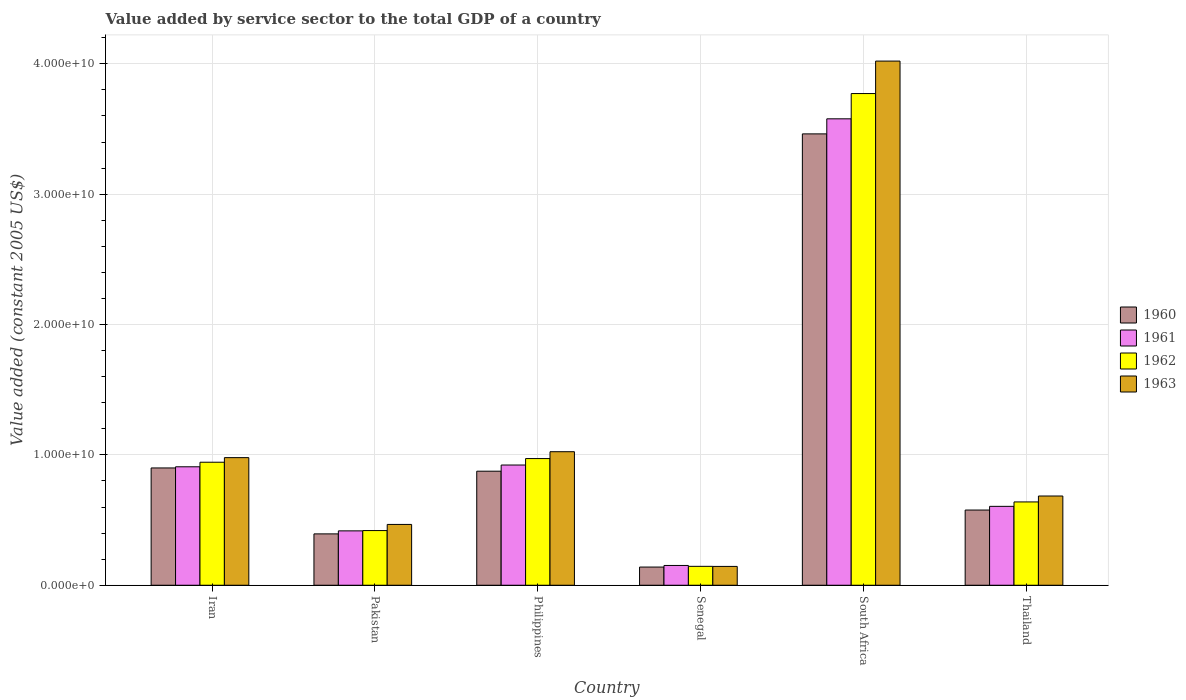How many different coloured bars are there?
Offer a terse response. 4. Are the number of bars per tick equal to the number of legend labels?
Provide a succinct answer. Yes. How many bars are there on the 2nd tick from the right?
Give a very brief answer. 4. What is the value added by service sector in 1960 in Pakistan?
Provide a short and direct response. 3.94e+09. Across all countries, what is the maximum value added by service sector in 1962?
Provide a short and direct response. 3.77e+1. Across all countries, what is the minimum value added by service sector in 1961?
Give a very brief answer. 1.52e+09. In which country was the value added by service sector in 1960 maximum?
Your answer should be compact. South Africa. In which country was the value added by service sector in 1961 minimum?
Your response must be concise. Senegal. What is the total value added by service sector in 1960 in the graph?
Offer a terse response. 6.35e+1. What is the difference between the value added by service sector in 1962 in Senegal and that in South Africa?
Provide a short and direct response. -3.63e+1. What is the difference between the value added by service sector in 1962 in South Africa and the value added by service sector in 1961 in Thailand?
Offer a terse response. 3.17e+1. What is the average value added by service sector in 1961 per country?
Your answer should be compact. 1.10e+1. What is the difference between the value added by service sector of/in 1960 and value added by service sector of/in 1963 in Senegal?
Offer a very short reply. -4.94e+07. In how many countries, is the value added by service sector in 1961 greater than 2000000000 US$?
Offer a terse response. 5. What is the ratio of the value added by service sector in 1963 in Senegal to that in Thailand?
Keep it short and to the point. 0.21. Is the difference between the value added by service sector in 1960 in Philippines and Senegal greater than the difference between the value added by service sector in 1963 in Philippines and Senegal?
Provide a short and direct response. No. What is the difference between the highest and the second highest value added by service sector in 1962?
Provide a succinct answer. -2.80e+1. What is the difference between the highest and the lowest value added by service sector in 1962?
Your answer should be compact. 3.63e+1. In how many countries, is the value added by service sector in 1961 greater than the average value added by service sector in 1961 taken over all countries?
Ensure brevity in your answer.  1. Is it the case that in every country, the sum of the value added by service sector in 1960 and value added by service sector in 1963 is greater than the value added by service sector in 1961?
Your answer should be compact. Yes. How many bars are there?
Your answer should be compact. 24. How many countries are there in the graph?
Your answer should be compact. 6. Are the values on the major ticks of Y-axis written in scientific E-notation?
Your answer should be very brief. Yes. How many legend labels are there?
Your answer should be compact. 4. What is the title of the graph?
Your answer should be compact. Value added by service sector to the total GDP of a country. What is the label or title of the X-axis?
Ensure brevity in your answer.  Country. What is the label or title of the Y-axis?
Offer a terse response. Value added (constant 2005 US$). What is the Value added (constant 2005 US$) in 1960 in Iran?
Provide a short and direct response. 9.00e+09. What is the Value added (constant 2005 US$) in 1961 in Iran?
Provide a short and direct response. 9.09e+09. What is the Value added (constant 2005 US$) of 1962 in Iran?
Your answer should be compact. 9.44e+09. What is the Value added (constant 2005 US$) in 1963 in Iran?
Offer a terse response. 9.79e+09. What is the Value added (constant 2005 US$) of 1960 in Pakistan?
Offer a terse response. 3.94e+09. What is the Value added (constant 2005 US$) of 1961 in Pakistan?
Offer a very short reply. 4.17e+09. What is the Value added (constant 2005 US$) of 1962 in Pakistan?
Your response must be concise. 4.19e+09. What is the Value added (constant 2005 US$) in 1963 in Pakistan?
Your answer should be compact. 4.66e+09. What is the Value added (constant 2005 US$) of 1960 in Philippines?
Ensure brevity in your answer.  8.75e+09. What is the Value added (constant 2005 US$) in 1961 in Philippines?
Offer a terse response. 9.22e+09. What is the Value added (constant 2005 US$) in 1962 in Philippines?
Your response must be concise. 9.72e+09. What is the Value added (constant 2005 US$) of 1963 in Philippines?
Your answer should be very brief. 1.02e+1. What is the Value added (constant 2005 US$) in 1960 in Senegal?
Make the answer very short. 1.39e+09. What is the Value added (constant 2005 US$) of 1961 in Senegal?
Ensure brevity in your answer.  1.52e+09. What is the Value added (constant 2005 US$) of 1962 in Senegal?
Offer a very short reply. 1.45e+09. What is the Value added (constant 2005 US$) of 1963 in Senegal?
Keep it short and to the point. 1.44e+09. What is the Value added (constant 2005 US$) of 1960 in South Africa?
Your answer should be compact. 3.46e+1. What is the Value added (constant 2005 US$) of 1961 in South Africa?
Keep it short and to the point. 3.58e+1. What is the Value added (constant 2005 US$) in 1962 in South Africa?
Your response must be concise. 3.77e+1. What is the Value added (constant 2005 US$) in 1963 in South Africa?
Offer a very short reply. 4.02e+1. What is the Value added (constant 2005 US$) in 1960 in Thailand?
Keep it short and to the point. 5.77e+09. What is the Value added (constant 2005 US$) in 1961 in Thailand?
Offer a very short reply. 6.05e+09. What is the Value added (constant 2005 US$) in 1962 in Thailand?
Ensure brevity in your answer.  6.39e+09. What is the Value added (constant 2005 US$) of 1963 in Thailand?
Offer a very short reply. 6.84e+09. Across all countries, what is the maximum Value added (constant 2005 US$) in 1960?
Offer a very short reply. 3.46e+1. Across all countries, what is the maximum Value added (constant 2005 US$) of 1961?
Keep it short and to the point. 3.58e+1. Across all countries, what is the maximum Value added (constant 2005 US$) in 1962?
Ensure brevity in your answer.  3.77e+1. Across all countries, what is the maximum Value added (constant 2005 US$) in 1963?
Give a very brief answer. 4.02e+1. Across all countries, what is the minimum Value added (constant 2005 US$) of 1960?
Your response must be concise. 1.39e+09. Across all countries, what is the minimum Value added (constant 2005 US$) in 1961?
Make the answer very short. 1.52e+09. Across all countries, what is the minimum Value added (constant 2005 US$) of 1962?
Offer a terse response. 1.45e+09. Across all countries, what is the minimum Value added (constant 2005 US$) in 1963?
Make the answer very short. 1.44e+09. What is the total Value added (constant 2005 US$) in 1960 in the graph?
Provide a succinct answer. 6.35e+1. What is the total Value added (constant 2005 US$) in 1961 in the graph?
Your response must be concise. 6.58e+1. What is the total Value added (constant 2005 US$) in 1962 in the graph?
Give a very brief answer. 6.89e+1. What is the total Value added (constant 2005 US$) in 1963 in the graph?
Your answer should be compact. 7.32e+1. What is the difference between the Value added (constant 2005 US$) in 1960 in Iran and that in Pakistan?
Make the answer very short. 5.06e+09. What is the difference between the Value added (constant 2005 US$) of 1961 in Iran and that in Pakistan?
Provide a short and direct response. 4.92e+09. What is the difference between the Value added (constant 2005 US$) in 1962 in Iran and that in Pakistan?
Offer a very short reply. 5.24e+09. What is the difference between the Value added (constant 2005 US$) of 1963 in Iran and that in Pakistan?
Ensure brevity in your answer.  5.12e+09. What is the difference between the Value added (constant 2005 US$) in 1960 in Iran and that in Philippines?
Offer a terse response. 2.49e+08. What is the difference between the Value added (constant 2005 US$) of 1961 in Iran and that in Philippines?
Your answer should be very brief. -1.35e+08. What is the difference between the Value added (constant 2005 US$) of 1962 in Iran and that in Philippines?
Your answer should be very brief. -2.80e+08. What is the difference between the Value added (constant 2005 US$) in 1963 in Iran and that in Philippines?
Keep it short and to the point. -4.54e+08. What is the difference between the Value added (constant 2005 US$) of 1960 in Iran and that in Senegal?
Ensure brevity in your answer.  7.60e+09. What is the difference between the Value added (constant 2005 US$) of 1961 in Iran and that in Senegal?
Your answer should be compact. 7.57e+09. What is the difference between the Value added (constant 2005 US$) in 1962 in Iran and that in Senegal?
Provide a short and direct response. 7.99e+09. What is the difference between the Value added (constant 2005 US$) of 1963 in Iran and that in Senegal?
Your response must be concise. 8.34e+09. What is the difference between the Value added (constant 2005 US$) of 1960 in Iran and that in South Africa?
Make the answer very short. -2.56e+1. What is the difference between the Value added (constant 2005 US$) in 1961 in Iran and that in South Africa?
Provide a short and direct response. -2.67e+1. What is the difference between the Value added (constant 2005 US$) of 1962 in Iran and that in South Africa?
Your answer should be very brief. -2.83e+1. What is the difference between the Value added (constant 2005 US$) in 1963 in Iran and that in South Africa?
Provide a succinct answer. -3.04e+1. What is the difference between the Value added (constant 2005 US$) in 1960 in Iran and that in Thailand?
Offer a very short reply. 3.23e+09. What is the difference between the Value added (constant 2005 US$) of 1961 in Iran and that in Thailand?
Provide a succinct answer. 3.03e+09. What is the difference between the Value added (constant 2005 US$) in 1962 in Iran and that in Thailand?
Offer a terse response. 3.05e+09. What is the difference between the Value added (constant 2005 US$) of 1963 in Iran and that in Thailand?
Your answer should be very brief. 2.94e+09. What is the difference between the Value added (constant 2005 US$) of 1960 in Pakistan and that in Philippines?
Your answer should be very brief. -4.81e+09. What is the difference between the Value added (constant 2005 US$) of 1961 in Pakistan and that in Philippines?
Offer a terse response. -5.05e+09. What is the difference between the Value added (constant 2005 US$) of 1962 in Pakistan and that in Philippines?
Your answer should be compact. -5.52e+09. What is the difference between the Value added (constant 2005 US$) in 1963 in Pakistan and that in Philippines?
Your answer should be very brief. -5.58e+09. What is the difference between the Value added (constant 2005 US$) of 1960 in Pakistan and that in Senegal?
Offer a terse response. 2.54e+09. What is the difference between the Value added (constant 2005 US$) of 1961 in Pakistan and that in Senegal?
Your response must be concise. 2.65e+09. What is the difference between the Value added (constant 2005 US$) of 1962 in Pakistan and that in Senegal?
Offer a very short reply. 2.74e+09. What is the difference between the Value added (constant 2005 US$) in 1963 in Pakistan and that in Senegal?
Your response must be concise. 3.22e+09. What is the difference between the Value added (constant 2005 US$) of 1960 in Pakistan and that in South Africa?
Your response must be concise. -3.07e+1. What is the difference between the Value added (constant 2005 US$) of 1961 in Pakistan and that in South Africa?
Your answer should be compact. -3.16e+1. What is the difference between the Value added (constant 2005 US$) in 1962 in Pakistan and that in South Africa?
Your response must be concise. -3.35e+1. What is the difference between the Value added (constant 2005 US$) in 1963 in Pakistan and that in South Africa?
Make the answer very short. -3.55e+1. What is the difference between the Value added (constant 2005 US$) in 1960 in Pakistan and that in Thailand?
Ensure brevity in your answer.  -1.83e+09. What is the difference between the Value added (constant 2005 US$) of 1961 in Pakistan and that in Thailand?
Make the answer very short. -1.88e+09. What is the difference between the Value added (constant 2005 US$) in 1962 in Pakistan and that in Thailand?
Make the answer very short. -2.20e+09. What is the difference between the Value added (constant 2005 US$) of 1963 in Pakistan and that in Thailand?
Keep it short and to the point. -2.18e+09. What is the difference between the Value added (constant 2005 US$) of 1960 in Philippines and that in Senegal?
Provide a short and direct response. 7.35e+09. What is the difference between the Value added (constant 2005 US$) in 1961 in Philippines and that in Senegal?
Provide a short and direct response. 7.70e+09. What is the difference between the Value added (constant 2005 US$) in 1962 in Philippines and that in Senegal?
Your answer should be very brief. 8.27e+09. What is the difference between the Value added (constant 2005 US$) in 1963 in Philippines and that in Senegal?
Provide a short and direct response. 8.80e+09. What is the difference between the Value added (constant 2005 US$) of 1960 in Philippines and that in South Africa?
Your answer should be very brief. -2.59e+1. What is the difference between the Value added (constant 2005 US$) in 1961 in Philippines and that in South Africa?
Ensure brevity in your answer.  -2.66e+1. What is the difference between the Value added (constant 2005 US$) of 1962 in Philippines and that in South Africa?
Offer a very short reply. -2.80e+1. What is the difference between the Value added (constant 2005 US$) in 1963 in Philippines and that in South Africa?
Your answer should be compact. -3.00e+1. What is the difference between the Value added (constant 2005 US$) in 1960 in Philippines and that in Thailand?
Provide a succinct answer. 2.98e+09. What is the difference between the Value added (constant 2005 US$) in 1961 in Philippines and that in Thailand?
Offer a very short reply. 3.17e+09. What is the difference between the Value added (constant 2005 US$) in 1962 in Philippines and that in Thailand?
Offer a very short reply. 3.33e+09. What is the difference between the Value added (constant 2005 US$) of 1963 in Philippines and that in Thailand?
Make the answer very short. 3.40e+09. What is the difference between the Value added (constant 2005 US$) in 1960 in Senegal and that in South Africa?
Offer a terse response. -3.32e+1. What is the difference between the Value added (constant 2005 US$) in 1961 in Senegal and that in South Africa?
Offer a very short reply. -3.43e+1. What is the difference between the Value added (constant 2005 US$) in 1962 in Senegal and that in South Africa?
Provide a succinct answer. -3.63e+1. What is the difference between the Value added (constant 2005 US$) in 1963 in Senegal and that in South Africa?
Your response must be concise. -3.88e+1. What is the difference between the Value added (constant 2005 US$) of 1960 in Senegal and that in Thailand?
Provide a succinct answer. -4.37e+09. What is the difference between the Value added (constant 2005 US$) in 1961 in Senegal and that in Thailand?
Give a very brief answer. -4.53e+09. What is the difference between the Value added (constant 2005 US$) in 1962 in Senegal and that in Thailand?
Your answer should be very brief. -4.94e+09. What is the difference between the Value added (constant 2005 US$) of 1963 in Senegal and that in Thailand?
Your answer should be compact. -5.40e+09. What is the difference between the Value added (constant 2005 US$) in 1960 in South Africa and that in Thailand?
Provide a short and direct response. 2.89e+1. What is the difference between the Value added (constant 2005 US$) in 1961 in South Africa and that in Thailand?
Offer a terse response. 2.97e+1. What is the difference between the Value added (constant 2005 US$) in 1962 in South Africa and that in Thailand?
Offer a very short reply. 3.13e+1. What is the difference between the Value added (constant 2005 US$) of 1963 in South Africa and that in Thailand?
Your answer should be compact. 3.34e+1. What is the difference between the Value added (constant 2005 US$) in 1960 in Iran and the Value added (constant 2005 US$) in 1961 in Pakistan?
Your answer should be very brief. 4.83e+09. What is the difference between the Value added (constant 2005 US$) in 1960 in Iran and the Value added (constant 2005 US$) in 1962 in Pakistan?
Provide a succinct answer. 4.80e+09. What is the difference between the Value added (constant 2005 US$) in 1960 in Iran and the Value added (constant 2005 US$) in 1963 in Pakistan?
Your response must be concise. 4.33e+09. What is the difference between the Value added (constant 2005 US$) of 1961 in Iran and the Value added (constant 2005 US$) of 1962 in Pakistan?
Keep it short and to the point. 4.89e+09. What is the difference between the Value added (constant 2005 US$) in 1961 in Iran and the Value added (constant 2005 US$) in 1963 in Pakistan?
Give a very brief answer. 4.42e+09. What is the difference between the Value added (constant 2005 US$) of 1962 in Iran and the Value added (constant 2005 US$) of 1963 in Pakistan?
Provide a succinct answer. 4.77e+09. What is the difference between the Value added (constant 2005 US$) of 1960 in Iran and the Value added (constant 2005 US$) of 1961 in Philippines?
Provide a succinct answer. -2.24e+08. What is the difference between the Value added (constant 2005 US$) of 1960 in Iran and the Value added (constant 2005 US$) of 1962 in Philippines?
Provide a short and direct response. -7.19e+08. What is the difference between the Value added (constant 2005 US$) of 1960 in Iran and the Value added (constant 2005 US$) of 1963 in Philippines?
Make the answer very short. -1.25e+09. What is the difference between the Value added (constant 2005 US$) of 1961 in Iran and the Value added (constant 2005 US$) of 1962 in Philippines?
Make the answer very short. -6.30e+08. What is the difference between the Value added (constant 2005 US$) in 1961 in Iran and the Value added (constant 2005 US$) in 1963 in Philippines?
Your response must be concise. -1.16e+09. What is the difference between the Value added (constant 2005 US$) in 1962 in Iran and the Value added (constant 2005 US$) in 1963 in Philippines?
Provide a succinct answer. -8.07e+08. What is the difference between the Value added (constant 2005 US$) in 1960 in Iran and the Value added (constant 2005 US$) in 1961 in Senegal?
Offer a terse response. 7.48e+09. What is the difference between the Value added (constant 2005 US$) of 1960 in Iran and the Value added (constant 2005 US$) of 1962 in Senegal?
Provide a short and direct response. 7.55e+09. What is the difference between the Value added (constant 2005 US$) of 1960 in Iran and the Value added (constant 2005 US$) of 1963 in Senegal?
Provide a short and direct response. 7.55e+09. What is the difference between the Value added (constant 2005 US$) in 1961 in Iran and the Value added (constant 2005 US$) in 1962 in Senegal?
Provide a succinct answer. 7.64e+09. What is the difference between the Value added (constant 2005 US$) in 1961 in Iran and the Value added (constant 2005 US$) in 1963 in Senegal?
Your answer should be very brief. 7.64e+09. What is the difference between the Value added (constant 2005 US$) of 1962 in Iran and the Value added (constant 2005 US$) of 1963 in Senegal?
Ensure brevity in your answer.  7.99e+09. What is the difference between the Value added (constant 2005 US$) in 1960 in Iran and the Value added (constant 2005 US$) in 1961 in South Africa?
Keep it short and to the point. -2.68e+1. What is the difference between the Value added (constant 2005 US$) in 1960 in Iran and the Value added (constant 2005 US$) in 1962 in South Africa?
Offer a very short reply. -2.87e+1. What is the difference between the Value added (constant 2005 US$) in 1960 in Iran and the Value added (constant 2005 US$) in 1963 in South Africa?
Provide a succinct answer. -3.12e+1. What is the difference between the Value added (constant 2005 US$) in 1961 in Iran and the Value added (constant 2005 US$) in 1962 in South Africa?
Keep it short and to the point. -2.86e+1. What is the difference between the Value added (constant 2005 US$) in 1961 in Iran and the Value added (constant 2005 US$) in 1963 in South Africa?
Keep it short and to the point. -3.11e+1. What is the difference between the Value added (constant 2005 US$) in 1962 in Iran and the Value added (constant 2005 US$) in 1963 in South Africa?
Your answer should be compact. -3.08e+1. What is the difference between the Value added (constant 2005 US$) of 1960 in Iran and the Value added (constant 2005 US$) of 1961 in Thailand?
Your answer should be compact. 2.95e+09. What is the difference between the Value added (constant 2005 US$) of 1960 in Iran and the Value added (constant 2005 US$) of 1962 in Thailand?
Your response must be concise. 2.61e+09. What is the difference between the Value added (constant 2005 US$) in 1960 in Iran and the Value added (constant 2005 US$) in 1963 in Thailand?
Provide a short and direct response. 2.15e+09. What is the difference between the Value added (constant 2005 US$) in 1961 in Iran and the Value added (constant 2005 US$) in 1962 in Thailand?
Ensure brevity in your answer.  2.70e+09. What is the difference between the Value added (constant 2005 US$) in 1961 in Iran and the Value added (constant 2005 US$) in 1963 in Thailand?
Your response must be concise. 2.24e+09. What is the difference between the Value added (constant 2005 US$) of 1962 in Iran and the Value added (constant 2005 US$) of 1963 in Thailand?
Provide a short and direct response. 2.59e+09. What is the difference between the Value added (constant 2005 US$) of 1960 in Pakistan and the Value added (constant 2005 US$) of 1961 in Philippines?
Your answer should be compact. -5.28e+09. What is the difference between the Value added (constant 2005 US$) of 1960 in Pakistan and the Value added (constant 2005 US$) of 1962 in Philippines?
Your answer should be compact. -5.78e+09. What is the difference between the Value added (constant 2005 US$) in 1960 in Pakistan and the Value added (constant 2005 US$) in 1963 in Philippines?
Your response must be concise. -6.30e+09. What is the difference between the Value added (constant 2005 US$) in 1961 in Pakistan and the Value added (constant 2005 US$) in 1962 in Philippines?
Offer a terse response. -5.55e+09. What is the difference between the Value added (constant 2005 US$) in 1961 in Pakistan and the Value added (constant 2005 US$) in 1963 in Philippines?
Offer a very short reply. -6.07e+09. What is the difference between the Value added (constant 2005 US$) in 1962 in Pakistan and the Value added (constant 2005 US$) in 1963 in Philippines?
Offer a terse response. -6.05e+09. What is the difference between the Value added (constant 2005 US$) in 1960 in Pakistan and the Value added (constant 2005 US$) in 1961 in Senegal?
Keep it short and to the point. 2.42e+09. What is the difference between the Value added (constant 2005 US$) in 1960 in Pakistan and the Value added (constant 2005 US$) in 1962 in Senegal?
Give a very brief answer. 2.49e+09. What is the difference between the Value added (constant 2005 US$) in 1960 in Pakistan and the Value added (constant 2005 US$) in 1963 in Senegal?
Offer a terse response. 2.49e+09. What is the difference between the Value added (constant 2005 US$) of 1961 in Pakistan and the Value added (constant 2005 US$) of 1962 in Senegal?
Ensure brevity in your answer.  2.72e+09. What is the difference between the Value added (constant 2005 US$) of 1961 in Pakistan and the Value added (constant 2005 US$) of 1963 in Senegal?
Offer a very short reply. 2.73e+09. What is the difference between the Value added (constant 2005 US$) of 1962 in Pakistan and the Value added (constant 2005 US$) of 1963 in Senegal?
Your response must be concise. 2.75e+09. What is the difference between the Value added (constant 2005 US$) in 1960 in Pakistan and the Value added (constant 2005 US$) in 1961 in South Africa?
Offer a terse response. -3.18e+1. What is the difference between the Value added (constant 2005 US$) of 1960 in Pakistan and the Value added (constant 2005 US$) of 1962 in South Africa?
Provide a succinct answer. -3.38e+1. What is the difference between the Value added (constant 2005 US$) of 1960 in Pakistan and the Value added (constant 2005 US$) of 1963 in South Africa?
Provide a succinct answer. -3.63e+1. What is the difference between the Value added (constant 2005 US$) in 1961 in Pakistan and the Value added (constant 2005 US$) in 1962 in South Africa?
Your answer should be compact. -3.35e+1. What is the difference between the Value added (constant 2005 US$) in 1961 in Pakistan and the Value added (constant 2005 US$) in 1963 in South Africa?
Provide a short and direct response. -3.60e+1. What is the difference between the Value added (constant 2005 US$) of 1962 in Pakistan and the Value added (constant 2005 US$) of 1963 in South Africa?
Give a very brief answer. -3.60e+1. What is the difference between the Value added (constant 2005 US$) in 1960 in Pakistan and the Value added (constant 2005 US$) in 1961 in Thailand?
Offer a terse response. -2.11e+09. What is the difference between the Value added (constant 2005 US$) in 1960 in Pakistan and the Value added (constant 2005 US$) in 1962 in Thailand?
Your answer should be very brief. -2.45e+09. What is the difference between the Value added (constant 2005 US$) in 1960 in Pakistan and the Value added (constant 2005 US$) in 1963 in Thailand?
Your answer should be very brief. -2.91e+09. What is the difference between the Value added (constant 2005 US$) of 1961 in Pakistan and the Value added (constant 2005 US$) of 1962 in Thailand?
Make the answer very short. -2.22e+09. What is the difference between the Value added (constant 2005 US$) in 1961 in Pakistan and the Value added (constant 2005 US$) in 1963 in Thailand?
Make the answer very short. -2.67e+09. What is the difference between the Value added (constant 2005 US$) of 1962 in Pakistan and the Value added (constant 2005 US$) of 1963 in Thailand?
Provide a short and direct response. -2.65e+09. What is the difference between the Value added (constant 2005 US$) in 1960 in Philippines and the Value added (constant 2005 US$) in 1961 in Senegal?
Keep it short and to the point. 7.23e+09. What is the difference between the Value added (constant 2005 US$) of 1960 in Philippines and the Value added (constant 2005 US$) of 1962 in Senegal?
Keep it short and to the point. 7.30e+09. What is the difference between the Value added (constant 2005 US$) in 1960 in Philippines and the Value added (constant 2005 US$) in 1963 in Senegal?
Offer a terse response. 7.30e+09. What is the difference between the Value added (constant 2005 US$) of 1961 in Philippines and the Value added (constant 2005 US$) of 1962 in Senegal?
Make the answer very short. 7.77e+09. What is the difference between the Value added (constant 2005 US$) in 1961 in Philippines and the Value added (constant 2005 US$) in 1963 in Senegal?
Give a very brief answer. 7.78e+09. What is the difference between the Value added (constant 2005 US$) in 1962 in Philippines and the Value added (constant 2005 US$) in 1963 in Senegal?
Offer a terse response. 8.27e+09. What is the difference between the Value added (constant 2005 US$) in 1960 in Philippines and the Value added (constant 2005 US$) in 1961 in South Africa?
Make the answer very short. -2.70e+1. What is the difference between the Value added (constant 2005 US$) in 1960 in Philippines and the Value added (constant 2005 US$) in 1962 in South Africa?
Your answer should be very brief. -2.90e+1. What is the difference between the Value added (constant 2005 US$) in 1960 in Philippines and the Value added (constant 2005 US$) in 1963 in South Africa?
Your answer should be compact. -3.15e+1. What is the difference between the Value added (constant 2005 US$) of 1961 in Philippines and the Value added (constant 2005 US$) of 1962 in South Africa?
Provide a succinct answer. -2.85e+1. What is the difference between the Value added (constant 2005 US$) in 1961 in Philippines and the Value added (constant 2005 US$) in 1963 in South Africa?
Keep it short and to the point. -3.10e+1. What is the difference between the Value added (constant 2005 US$) of 1962 in Philippines and the Value added (constant 2005 US$) of 1963 in South Africa?
Provide a succinct answer. -3.05e+1. What is the difference between the Value added (constant 2005 US$) in 1960 in Philippines and the Value added (constant 2005 US$) in 1961 in Thailand?
Your answer should be compact. 2.70e+09. What is the difference between the Value added (constant 2005 US$) of 1960 in Philippines and the Value added (constant 2005 US$) of 1962 in Thailand?
Provide a succinct answer. 2.36e+09. What is the difference between the Value added (constant 2005 US$) of 1960 in Philippines and the Value added (constant 2005 US$) of 1963 in Thailand?
Give a very brief answer. 1.90e+09. What is the difference between the Value added (constant 2005 US$) of 1961 in Philippines and the Value added (constant 2005 US$) of 1962 in Thailand?
Your answer should be very brief. 2.83e+09. What is the difference between the Value added (constant 2005 US$) of 1961 in Philippines and the Value added (constant 2005 US$) of 1963 in Thailand?
Offer a very short reply. 2.38e+09. What is the difference between the Value added (constant 2005 US$) of 1962 in Philippines and the Value added (constant 2005 US$) of 1963 in Thailand?
Give a very brief answer. 2.87e+09. What is the difference between the Value added (constant 2005 US$) of 1960 in Senegal and the Value added (constant 2005 US$) of 1961 in South Africa?
Your answer should be compact. -3.44e+1. What is the difference between the Value added (constant 2005 US$) of 1960 in Senegal and the Value added (constant 2005 US$) of 1962 in South Africa?
Your answer should be compact. -3.63e+1. What is the difference between the Value added (constant 2005 US$) in 1960 in Senegal and the Value added (constant 2005 US$) in 1963 in South Africa?
Your response must be concise. -3.88e+1. What is the difference between the Value added (constant 2005 US$) in 1961 in Senegal and the Value added (constant 2005 US$) in 1962 in South Africa?
Offer a very short reply. -3.62e+1. What is the difference between the Value added (constant 2005 US$) of 1961 in Senegal and the Value added (constant 2005 US$) of 1963 in South Africa?
Your answer should be very brief. -3.87e+1. What is the difference between the Value added (constant 2005 US$) in 1962 in Senegal and the Value added (constant 2005 US$) in 1963 in South Africa?
Your answer should be compact. -3.88e+1. What is the difference between the Value added (constant 2005 US$) in 1960 in Senegal and the Value added (constant 2005 US$) in 1961 in Thailand?
Your answer should be very brief. -4.66e+09. What is the difference between the Value added (constant 2005 US$) of 1960 in Senegal and the Value added (constant 2005 US$) of 1962 in Thailand?
Give a very brief answer. -5.00e+09. What is the difference between the Value added (constant 2005 US$) in 1960 in Senegal and the Value added (constant 2005 US$) in 1963 in Thailand?
Provide a succinct answer. -5.45e+09. What is the difference between the Value added (constant 2005 US$) in 1961 in Senegal and the Value added (constant 2005 US$) in 1962 in Thailand?
Ensure brevity in your answer.  -4.87e+09. What is the difference between the Value added (constant 2005 US$) in 1961 in Senegal and the Value added (constant 2005 US$) in 1963 in Thailand?
Give a very brief answer. -5.33e+09. What is the difference between the Value added (constant 2005 US$) of 1962 in Senegal and the Value added (constant 2005 US$) of 1963 in Thailand?
Your answer should be compact. -5.39e+09. What is the difference between the Value added (constant 2005 US$) of 1960 in South Africa and the Value added (constant 2005 US$) of 1961 in Thailand?
Keep it short and to the point. 2.86e+1. What is the difference between the Value added (constant 2005 US$) of 1960 in South Africa and the Value added (constant 2005 US$) of 1962 in Thailand?
Your answer should be compact. 2.82e+1. What is the difference between the Value added (constant 2005 US$) in 1960 in South Africa and the Value added (constant 2005 US$) in 1963 in Thailand?
Your answer should be compact. 2.78e+1. What is the difference between the Value added (constant 2005 US$) in 1961 in South Africa and the Value added (constant 2005 US$) in 1962 in Thailand?
Your response must be concise. 2.94e+1. What is the difference between the Value added (constant 2005 US$) in 1961 in South Africa and the Value added (constant 2005 US$) in 1963 in Thailand?
Provide a succinct answer. 2.89e+1. What is the difference between the Value added (constant 2005 US$) in 1962 in South Africa and the Value added (constant 2005 US$) in 1963 in Thailand?
Your answer should be compact. 3.09e+1. What is the average Value added (constant 2005 US$) in 1960 per country?
Provide a short and direct response. 1.06e+1. What is the average Value added (constant 2005 US$) in 1961 per country?
Your answer should be compact. 1.10e+1. What is the average Value added (constant 2005 US$) in 1962 per country?
Your answer should be compact. 1.15e+1. What is the average Value added (constant 2005 US$) in 1963 per country?
Your answer should be very brief. 1.22e+1. What is the difference between the Value added (constant 2005 US$) in 1960 and Value added (constant 2005 US$) in 1961 in Iran?
Keep it short and to the point. -8.88e+07. What is the difference between the Value added (constant 2005 US$) in 1960 and Value added (constant 2005 US$) in 1962 in Iran?
Ensure brevity in your answer.  -4.39e+08. What is the difference between the Value added (constant 2005 US$) in 1960 and Value added (constant 2005 US$) in 1963 in Iran?
Your response must be concise. -7.91e+08. What is the difference between the Value added (constant 2005 US$) of 1961 and Value added (constant 2005 US$) of 1962 in Iran?
Ensure brevity in your answer.  -3.50e+08. What is the difference between the Value added (constant 2005 US$) in 1961 and Value added (constant 2005 US$) in 1963 in Iran?
Provide a succinct answer. -7.02e+08. What is the difference between the Value added (constant 2005 US$) in 1962 and Value added (constant 2005 US$) in 1963 in Iran?
Offer a very short reply. -3.52e+08. What is the difference between the Value added (constant 2005 US$) of 1960 and Value added (constant 2005 US$) of 1961 in Pakistan?
Make the answer very short. -2.32e+08. What is the difference between the Value added (constant 2005 US$) of 1960 and Value added (constant 2005 US$) of 1962 in Pakistan?
Make the answer very short. -2.54e+08. What is the difference between the Value added (constant 2005 US$) in 1960 and Value added (constant 2005 US$) in 1963 in Pakistan?
Provide a short and direct response. -7.25e+08. What is the difference between the Value added (constant 2005 US$) of 1961 and Value added (constant 2005 US$) of 1962 in Pakistan?
Provide a short and direct response. -2.26e+07. What is the difference between the Value added (constant 2005 US$) in 1961 and Value added (constant 2005 US$) in 1963 in Pakistan?
Keep it short and to the point. -4.93e+08. What is the difference between the Value added (constant 2005 US$) in 1962 and Value added (constant 2005 US$) in 1963 in Pakistan?
Provide a succinct answer. -4.71e+08. What is the difference between the Value added (constant 2005 US$) in 1960 and Value added (constant 2005 US$) in 1961 in Philippines?
Keep it short and to the point. -4.73e+08. What is the difference between the Value added (constant 2005 US$) of 1960 and Value added (constant 2005 US$) of 1962 in Philippines?
Offer a terse response. -9.68e+08. What is the difference between the Value added (constant 2005 US$) of 1960 and Value added (constant 2005 US$) of 1963 in Philippines?
Your response must be concise. -1.49e+09. What is the difference between the Value added (constant 2005 US$) of 1961 and Value added (constant 2005 US$) of 1962 in Philippines?
Provide a succinct answer. -4.95e+08. What is the difference between the Value added (constant 2005 US$) of 1961 and Value added (constant 2005 US$) of 1963 in Philippines?
Provide a succinct answer. -1.02e+09. What is the difference between the Value added (constant 2005 US$) in 1962 and Value added (constant 2005 US$) in 1963 in Philippines?
Give a very brief answer. -5.27e+08. What is the difference between the Value added (constant 2005 US$) in 1960 and Value added (constant 2005 US$) in 1961 in Senegal?
Provide a short and direct response. -1.22e+08. What is the difference between the Value added (constant 2005 US$) in 1960 and Value added (constant 2005 US$) in 1962 in Senegal?
Keep it short and to the point. -5.52e+07. What is the difference between the Value added (constant 2005 US$) of 1960 and Value added (constant 2005 US$) of 1963 in Senegal?
Your answer should be compact. -4.94e+07. What is the difference between the Value added (constant 2005 US$) of 1961 and Value added (constant 2005 US$) of 1962 in Senegal?
Offer a very short reply. 6.67e+07. What is the difference between the Value added (constant 2005 US$) in 1961 and Value added (constant 2005 US$) in 1963 in Senegal?
Your response must be concise. 7.25e+07. What is the difference between the Value added (constant 2005 US$) in 1962 and Value added (constant 2005 US$) in 1963 in Senegal?
Make the answer very short. 5.77e+06. What is the difference between the Value added (constant 2005 US$) of 1960 and Value added (constant 2005 US$) of 1961 in South Africa?
Ensure brevity in your answer.  -1.16e+09. What is the difference between the Value added (constant 2005 US$) in 1960 and Value added (constant 2005 US$) in 1962 in South Africa?
Your answer should be very brief. -3.09e+09. What is the difference between the Value added (constant 2005 US$) in 1960 and Value added (constant 2005 US$) in 1963 in South Africa?
Offer a terse response. -5.58e+09. What is the difference between the Value added (constant 2005 US$) in 1961 and Value added (constant 2005 US$) in 1962 in South Africa?
Your response must be concise. -1.94e+09. What is the difference between the Value added (constant 2005 US$) of 1961 and Value added (constant 2005 US$) of 1963 in South Africa?
Your response must be concise. -4.43e+09. What is the difference between the Value added (constant 2005 US$) of 1962 and Value added (constant 2005 US$) of 1963 in South Africa?
Your answer should be very brief. -2.49e+09. What is the difference between the Value added (constant 2005 US$) in 1960 and Value added (constant 2005 US$) in 1961 in Thailand?
Your response must be concise. -2.83e+08. What is the difference between the Value added (constant 2005 US$) in 1960 and Value added (constant 2005 US$) in 1962 in Thailand?
Provide a short and direct response. -6.21e+08. What is the difference between the Value added (constant 2005 US$) of 1960 and Value added (constant 2005 US$) of 1963 in Thailand?
Ensure brevity in your answer.  -1.08e+09. What is the difference between the Value added (constant 2005 US$) in 1961 and Value added (constant 2005 US$) in 1962 in Thailand?
Provide a succinct answer. -3.39e+08. What is the difference between the Value added (constant 2005 US$) of 1961 and Value added (constant 2005 US$) of 1963 in Thailand?
Your answer should be compact. -7.93e+08. What is the difference between the Value added (constant 2005 US$) of 1962 and Value added (constant 2005 US$) of 1963 in Thailand?
Provide a short and direct response. -4.54e+08. What is the ratio of the Value added (constant 2005 US$) of 1960 in Iran to that in Pakistan?
Give a very brief answer. 2.28. What is the ratio of the Value added (constant 2005 US$) in 1961 in Iran to that in Pakistan?
Keep it short and to the point. 2.18. What is the ratio of the Value added (constant 2005 US$) in 1962 in Iran to that in Pakistan?
Keep it short and to the point. 2.25. What is the ratio of the Value added (constant 2005 US$) of 1963 in Iran to that in Pakistan?
Keep it short and to the point. 2.1. What is the ratio of the Value added (constant 2005 US$) in 1960 in Iran to that in Philippines?
Give a very brief answer. 1.03. What is the ratio of the Value added (constant 2005 US$) in 1961 in Iran to that in Philippines?
Offer a terse response. 0.99. What is the ratio of the Value added (constant 2005 US$) of 1962 in Iran to that in Philippines?
Offer a very short reply. 0.97. What is the ratio of the Value added (constant 2005 US$) of 1963 in Iran to that in Philippines?
Give a very brief answer. 0.96. What is the ratio of the Value added (constant 2005 US$) of 1960 in Iran to that in Senegal?
Give a very brief answer. 6.45. What is the ratio of the Value added (constant 2005 US$) of 1961 in Iran to that in Senegal?
Give a very brief answer. 5.99. What is the ratio of the Value added (constant 2005 US$) of 1962 in Iran to that in Senegal?
Offer a very short reply. 6.51. What is the ratio of the Value added (constant 2005 US$) of 1963 in Iran to that in Senegal?
Your answer should be compact. 6.78. What is the ratio of the Value added (constant 2005 US$) in 1960 in Iran to that in South Africa?
Keep it short and to the point. 0.26. What is the ratio of the Value added (constant 2005 US$) in 1961 in Iran to that in South Africa?
Your answer should be very brief. 0.25. What is the ratio of the Value added (constant 2005 US$) of 1962 in Iran to that in South Africa?
Your answer should be compact. 0.25. What is the ratio of the Value added (constant 2005 US$) in 1963 in Iran to that in South Africa?
Your answer should be compact. 0.24. What is the ratio of the Value added (constant 2005 US$) of 1960 in Iran to that in Thailand?
Provide a succinct answer. 1.56. What is the ratio of the Value added (constant 2005 US$) in 1961 in Iran to that in Thailand?
Your answer should be very brief. 1.5. What is the ratio of the Value added (constant 2005 US$) of 1962 in Iran to that in Thailand?
Your answer should be very brief. 1.48. What is the ratio of the Value added (constant 2005 US$) of 1963 in Iran to that in Thailand?
Make the answer very short. 1.43. What is the ratio of the Value added (constant 2005 US$) of 1960 in Pakistan to that in Philippines?
Keep it short and to the point. 0.45. What is the ratio of the Value added (constant 2005 US$) in 1961 in Pakistan to that in Philippines?
Give a very brief answer. 0.45. What is the ratio of the Value added (constant 2005 US$) of 1962 in Pakistan to that in Philippines?
Keep it short and to the point. 0.43. What is the ratio of the Value added (constant 2005 US$) of 1963 in Pakistan to that in Philippines?
Your answer should be very brief. 0.46. What is the ratio of the Value added (constant 2005 US$) in 1960 in Pakistan to that in Senegal?
Your response must be concise. 2.82. What is the ratio of the Value added (constant 2005 US$) in 1961 in Pakistan to that in Senegal?
Provide a short and direct response. 2.75. What is the ratio of the Value added (constant 2005 US$) in 1962 in Pakistan to that in Senegal?
Your answer should be very brief. 2.89. What is the ratio of the Value added (constant 2005 US$) of 1963 in Pakistan to that in Senegal?
Ensure brevity in your answer.  3.23. What is the ratio of the Value added (constant 2005 US$) in 1960 in Pakistan to that in South Africa?
Ensure brevity in your answer.  0.11. What is the ratio of the Value added (constant 2005 US$) of 1961 in Pakistan to that in South Africa?
Make the answer very short. 0.12. What is the ratio of the Value added (constant 2005 US$) of 1962 in Pakistan to that in South Africa?
Your answer should be very brief. 0.11. What is the ratio of the Value added (constant 2005 US$) of 1963 in Pakistan to that in South Africa?
Keep it short and to the point. 0.12. What is the ratio of the Value added (constant 2005 US$) in 1960 in Pakistan to that in Thailand?
Your answer should be compact. 0.68. What is the ratio of the Value added (constant 2005 US$) of 1961 in Pakistan to that in Thailand?
Provide a succinct answer. 0.69. What is the ratio of the Value added (constant 2005 US$) in 1962 in Pakistan to that in Thailand?
Keep it short and to the point. 0.66. What is the ratio of the Value added (constant 2005 US$) of 1963 in Pakistan to that in Thailand?
Your answer should be compact. 0.68. What is the ratio of the Value added (constant 2005 US$) of 1960 in Philippines to that in Senegal?
Your answer should be compact. 6.27. What is the ratio of the Value added (constant 2005 US$) of 1961 in Philippines to that in Senegal?
Offer a very short reply. 6.08. What is the ratio of the Value added (constant 2005 US$) in 1962 in Philippines to that in Senegal?
Offer a terse response. 6.7. What is the ratio of the Value added (constant 2005 US$) in 1963 in Philippines to that in Senegal?
Your response must be concise. 7.09. What is the ratio of the Value added (constant 2005 US$) in 1960 in Philippines to that in South Africa?
Your answer should be very brief. 0.25. What is the ratio of the Value added (constant 2005 US$) of 1961 in Philippines to that in South Africa?
Give a very brief answer. 0.26. What is the ratio of the Value added (constant 2005 US$) in 1962 in Philippines to that in South Africa?
Offer a very short reply. 0.26. What is the ratio of the Value added (constant 2005 US$) of 1963 in Philippines to that in South Africa?
Make the answer very short. 0.25. What is the ratio of the Value added (constant 2005 US$) of 1960 in Philippines to that in Thailand?
Offer a terse response. 1.52. What is the ratio of the Value added (constant 2005 US$) of 1961 in Philippines to that in Thailand?
Your answer should be compact. 1.52. What is the ratio of the Value added (constant 2005 US$) in 1962 in Philippines to that in Thailand?
Your answer should be compact. 1.52. What is the ratio of the Value added (constant 2005 US$) in 1963 in Philippines to that in Thailand?
Ensure brevity in your answer.  1.5. What is the ratio of the Value added (constant 2005 US$) of 1960 in Senegal to that in South Africa?
Your answer should be very brief. 0.04. What is the ratio of the Value added (constant 2005 US$) of 1961 in Senegal to that in South Africa?
Your response must be concise. 0.04. What is the ratio of the Value added (constant 2005 US$) in 1962 in Senegal to that in South Africa?
Offer a very short reply. 0.04. What is the ratio of the Value added (constant 2005 US$) of 1963 in Senegal to that in South Africa?
Give a very brief answer. 0.04. What is the ratio of the Value added (constant 2005 US$) of 1960 in Senegal to that in Thailand?
Provide a short and direct response. 0.24. What is the ratio of the Value added (constant 2005 US$) in 1961 in Senegal to that in Thailand?
Provide a succinct answer. 0.25. What is the ratio of the Value added (constant 2005 US$) of 1962 in Senegal to that in Thailand?
Provide a succinct answer. 0.23. What is the ratio of the Value added (constant 2005 US$) of 1963 in Senegal to that in Thailand?
Your response must be concise. 0.21. What is the ratio of the Value added (constant 2005 US$) of 1960 in South Africa to that in Thailand?
Make the answer very short. 6. What is the ratio of the Value added (constant 2005 US$) in 1961 in South Africa to that in Thailand?
Keep it short and to the point. 5.91. What is the ratio of the Value added (constant 2005 US$) in 1962 in South Africa to that in Thailand?
Your answer should be very brief. 5.9. What is the ratio of the Value added (constant 2005 US$) in 1963 in South Africa to that in Thailand?
Provide a short and direct response. 5.87. What is the difference between the highest and the second highest Value added (constant 2005 US$) in 1960?
Ensure brevity in your answer.  2.56e+1. What is the difference between the highest and the second highest Value added (constant 2005 US$) in 1961?
Offer a terse response. 2.66e+1. What is the difference between the highest and the second highest Value added (constant 2005 US$) of 1962?
Offer a very short reply. 2.80e+1. What is the difference between the highest and the second highest Value added (constant 2005 US$) of 1963?
Your response must be concise. 3.00e+1. What is the difference between the highest and the lowest Value added (constant 2005 US$) in 1960?
Your answer should be very brief. 3.32e+1. What is the difference between the highest and the lowest Value added (constant 2005 US$) in 1961?
Give a very brief answer. 3.43e+1. What is the difference between the highest and the lowest Value added (constant 2005 US$) in 1962?
Give a very brief answer. 3.63e+1. What is the difference between the highest and the lowest Value added (constant 2005 US$) in 1963?
Your answer should be compact. 3.88e+1. 